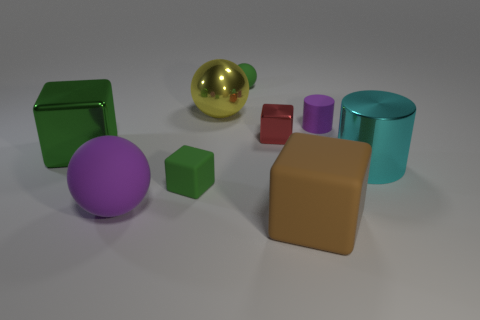Do the rubber cylinder and the big rubber ball have the same color?
Provide a short and direct response. Yes. There is a purple matte object right of the brown cube; how many green rubber spheres are behind it?
Keep it short and to the point. 1. What is the block that is in front of the large green object and behind the large brown matte thing made of?
Offer a very short reply. Rubber. The purple object that is the same size as the green matte ball is what shape?
Ensure brevity in your answer.  Cylinder. The matte ball that is left of the big sphere that is behind the large thing to the right of the big brown cube is what color?
Offer a very short reply. Purple. What number of objects are rubber objects right of the yellow thing or brown matte blocks?
Provide a succinct answer. 3. What material is the purple thing that is the same size as the green metal block?
Keep it short and to the point. Rubber. What material is the tiny object that is right of the big cube in front of the cylinder that is right of the small cylinder?
Provide a succinct answer. Rubber. The small matte ball has what color?
Provide a short and direct response. Green. What number of big things are either matte balls or brown things?
Give a very brief answer. 2. 